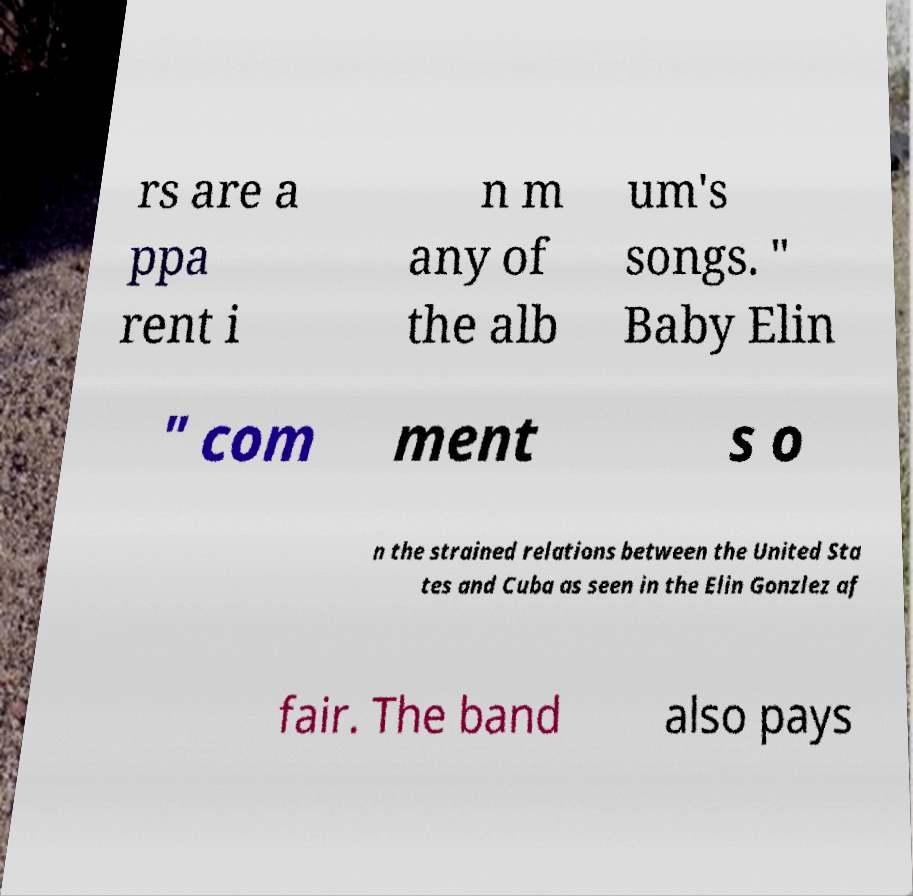Could you extract and type out the text from this image? rs are a ppa rent i n m any of the alb um's songs. " Baby Elin " com ment s o n the strained relations between the United Sta tes and Cuba as seen in the Elin Gonzlez af fair. The band also pays 